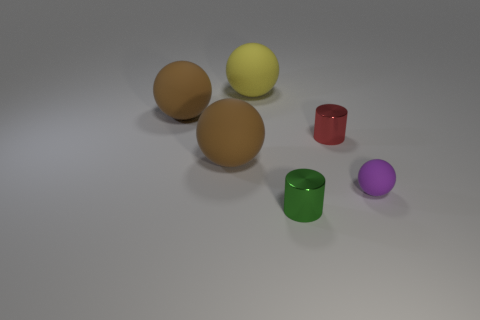Add 3 red metallic cylinders. How many objects exist? 9 Subtract all cylinders. How many objects are left? 4 Subtract 1 red cylinders. How many objects are left? 5 Subtract all big brown rubber things. Subtract all shiny objects. How many objects are left? 2 Add 3 large brown matte objects. How many large brown matte objects are left? 5 Add 1 tiny green things. How many tiny green things exist? 2 